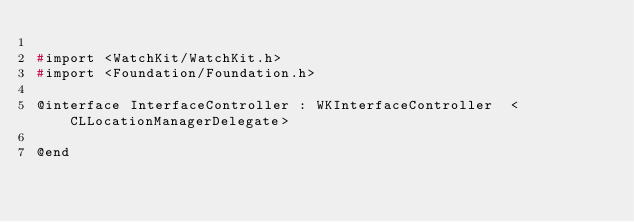Convert code to text. <code><loc_0><loc_0><loc_500><loc_500><_C_>
#import <WatchKit/WatchKit.h>
#import <Foundation/Foundation.h>

@interface InterfaceController : WKInterfaceController  <CLLocationManagerDelegate>

@end
</code> 